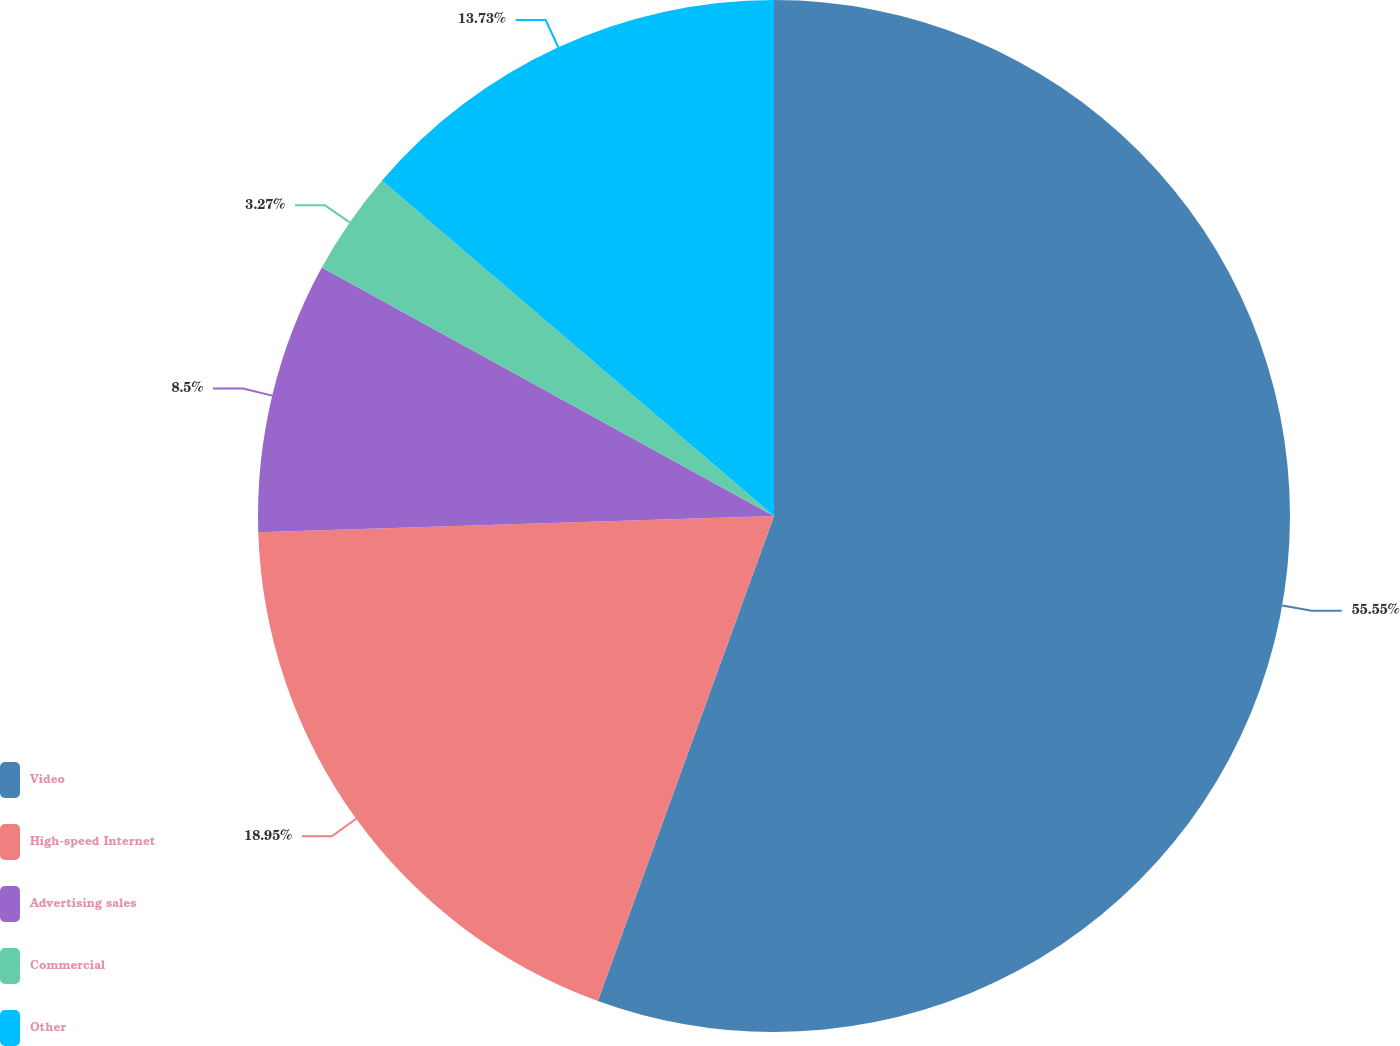<chart> <loc_0><loc_0><loc_500><loc_500><pie_chart><fcel>Video<fcel>High-speed Internet<fcel>Advertising sales<fcel>Commercial<fcel>Other<nl><fcel>55.54%<fcel>18.95%<fcel>8.5%<fcel>3.27%<fcel>13.73%<nl></chart> 